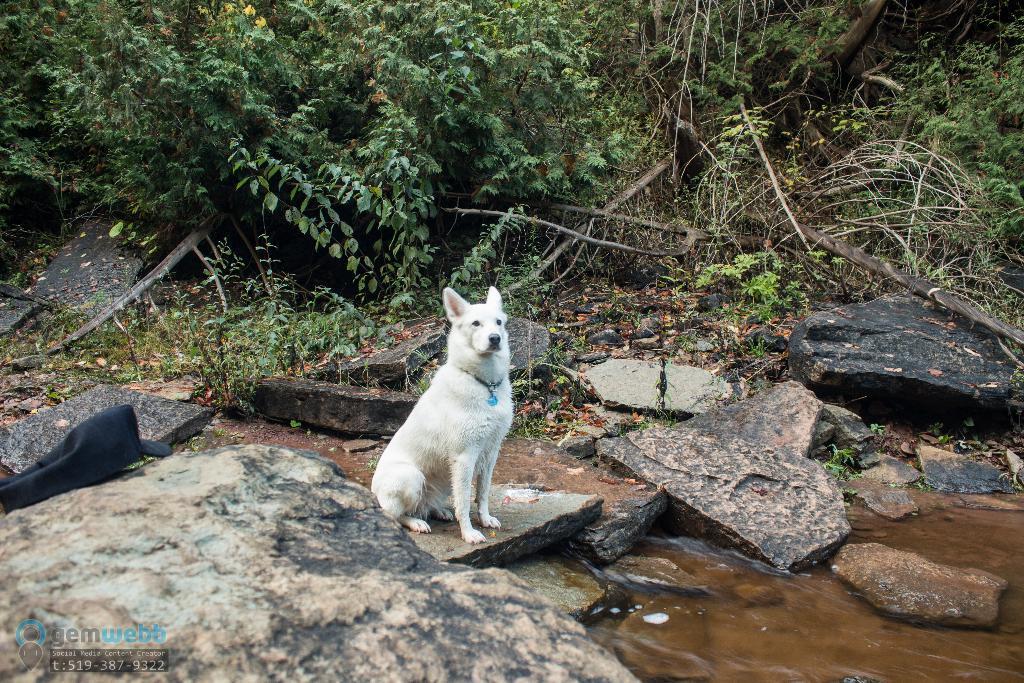Describe this image in one or two sentences. In the center of the image we can see a dog with neck band on the ground. In the foreground we can see water, group of rocks. In the background, we can see a group of trees. At the bottom we can see some text and numbers. 